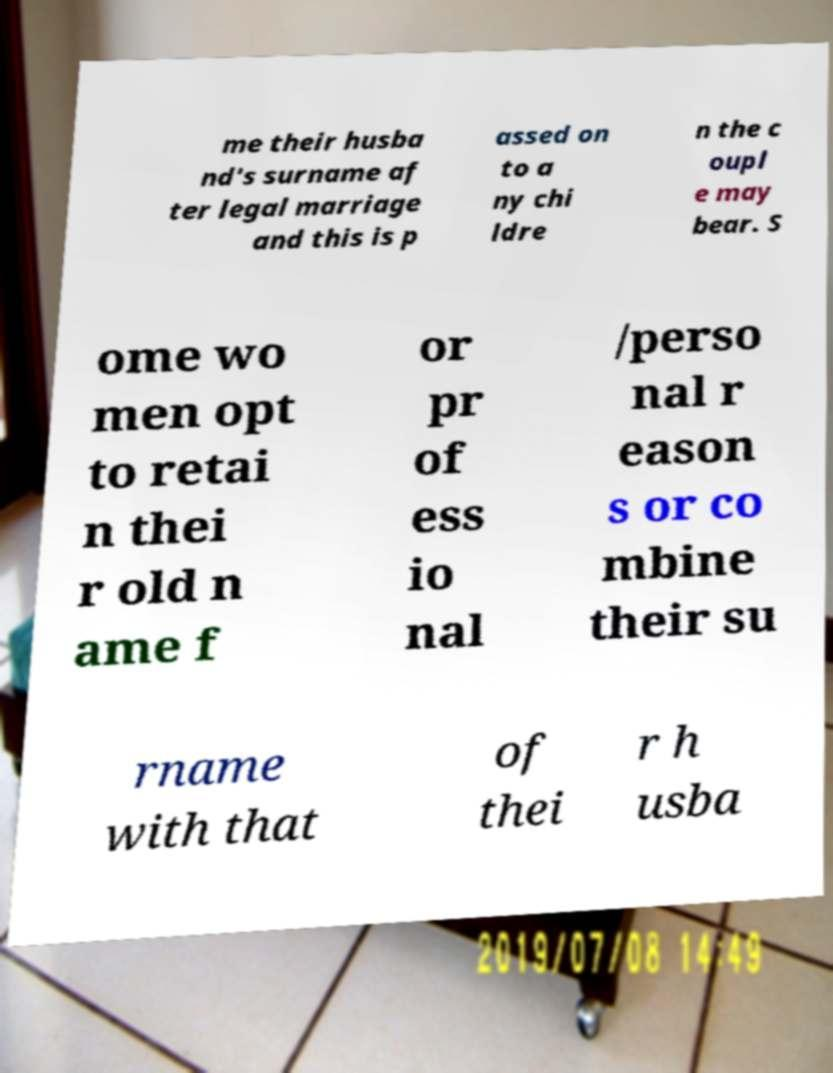Can you read and provide the text displayed in the image?This photo seems to have some interesting text. Can you extract and type it out for me? me their husba nd's surname af ter legal marriage and this is p assed on to a ny chi ldre n the c oupl e may bear. S ome wo men opt to retai n thei r old n ame f or pr of ess io nal /perso nal r eason s or co mbine their su rname with that of thei r h usba 